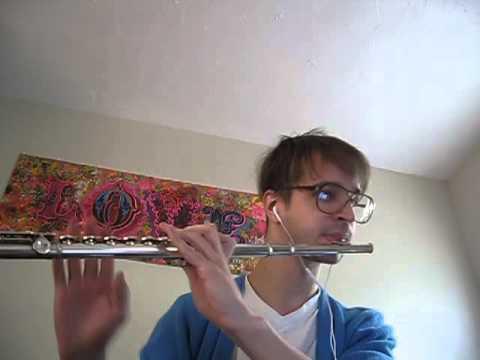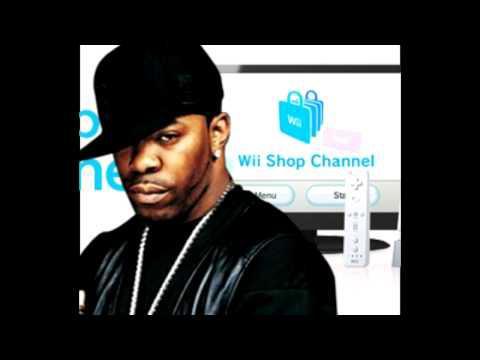The first image is the image on the left, the second image is the image on the right. Assess this claim about the two images: "Each image shows a male holding a flute to one nostril, and the right image features a man in a green frog-eye head covering and white shirt.". Correct or not? Answer yes or no. No. The first image is the image on the left, the second image is the image on the right. Examine the images to the left and right. Is the description "The left and right image contains the same number of men playing the flute and at least one man is wearing a green hat." accurate? Answer yes or no. No. 